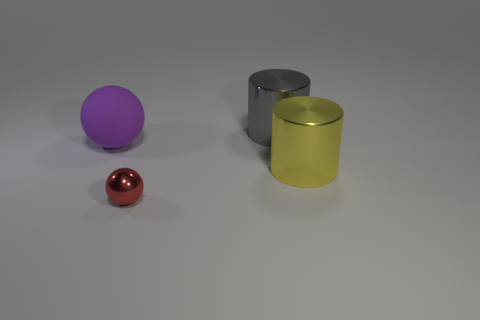Are there any other things that are the same material as the purple sphere?
Your answer should be compact. No. What is the color of the small shiny object?
Provide a short and direct response. Red. What is the color of the object that is in front of the large cylinder in front of the rubber object?
Offer a terse response. Red. Are there any red spheres made of the same material as the big gray object?
Provide a succinct answer. Yes. The ball behind the big metallic object that is in front of the big purple rubber sphere is made of what material?
Make the answer very short. Rubber. What number of purple matte objects have the same shape as the small red thing?
Your response must be concise. 1. What shape is the big rubber thing?
Ensure brevity in your answer.  Sphere. Are there fewer red shiny things than metallic objects?
Ensure brevity in your answer.  Yes. Are there any other things that are the same size as the red metallic ball?
Ensure brevity in your answer.  No. There is a small thing that is the same shape as the big purple rubber object; what is its material?
Ensure brevity in your answer.  Metal. 